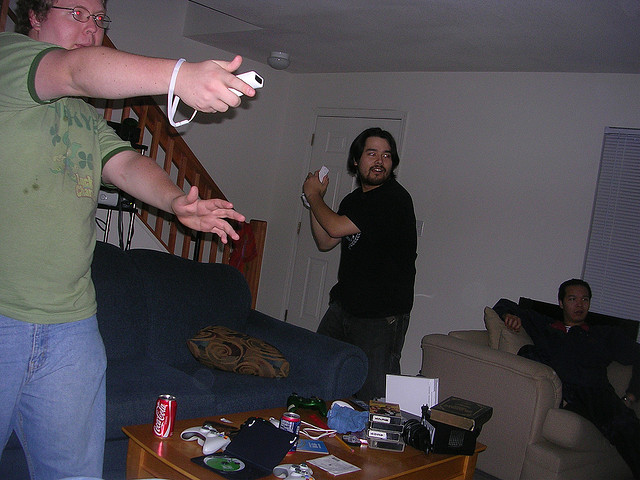Please transcribe the text information in this image. Coca Cola 